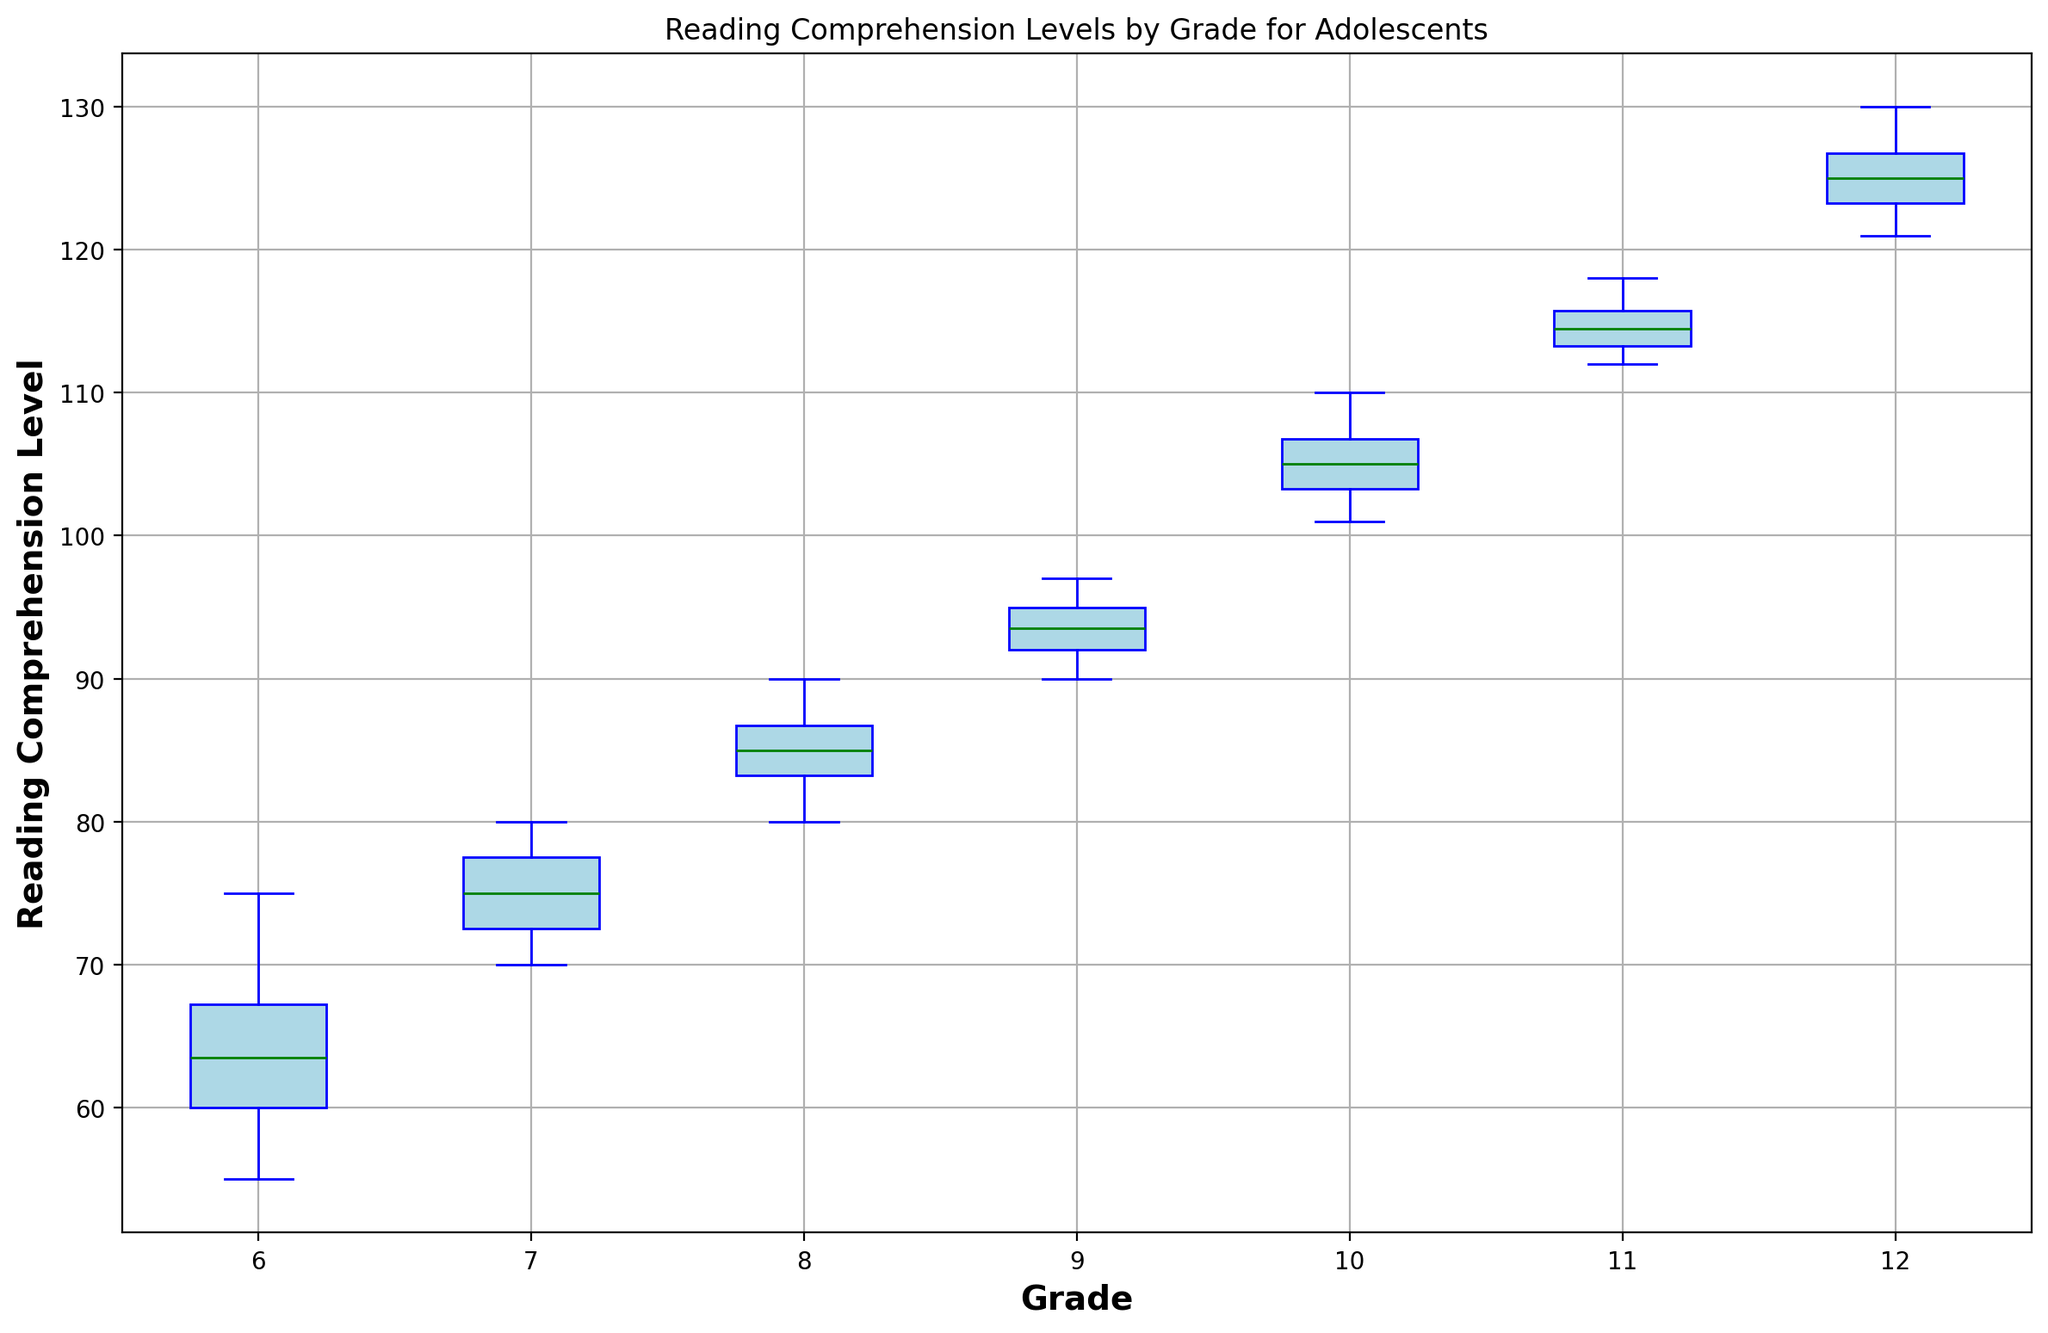what does the figure illustrate? The figure illustrates Reading Comprehension Levels for adolescents by grade using a box plot. Each grade's comprehension levels are displayed through a box plot that includes the median, quartiles, and any outliers.
Answer: Reading Comprehension Levels by Grade how does the median reading comprehension level change from grade 6 to grade 12? The median reading comprehension level increases as the grade level increases. Each box plot's green line, representing the median, moves higher from grade 6 to grade 12.
Answer: Increases which grade has the highest median reading comprehension level? By comparing the green lines in each box plot, grade 12 has the highest median reading comprehension level.
Answer: Grade 12 how do the interquartile ranges (IQR) compare between grade 6 and grade 10? The IQR is represented by the height of the box. The box for grade 6 is shorter than the box for grade 10, indicating that the IQR for grade 10 is larger than for grade 6.
Answer: Grade 10 has a larger IQR are there any outliers visible for any grade? Outliers are shown as red markers outside the whiskers of the box plots. There are no outliers visible for any grade from 6 to 12.
Answer: No what is the difference between the median reading comprehension levels of grades 9 and 8? The median for grade 9 is slightly higher than the median for grade 8. To find the difference, subtract the median of grade 8 (85) from the median of grade 9 (94).
Answer: 9 do grades 8 and 9 have overlapping reading comprehension levels? Overlapping can be identified by whiskers and boxes. The whiskers and boxes of grades 8 and 9 overlap, indicating some common ranges in their reading comprehension levels.
Answer: Yes which grade shows the most variation in reading comprehension levels? The grade with the longest whiskers and largest box indicates the most variation. Grade 12 shows the most variation compared to the others.
Answer: Grade 12 how does the upper quartile of grade 11 compare to the lower quartile of grade 12? The upper quartile of grade 11 and the lower quartile of grade 12 can be compared by the top edge of grade 11's box and the bottom edge of grade 12's box. Grade 12 has a higher lower quartile than the upper quartile of grade 11.
Answer: Grade 12's lower quartile is higher 